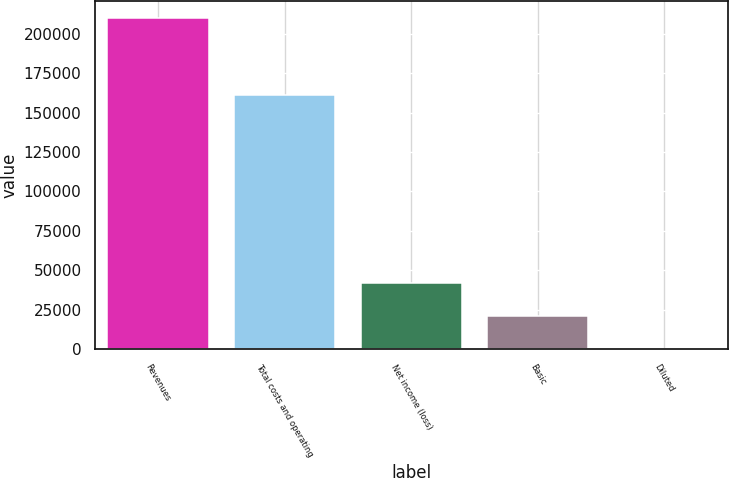<chart> <loc_0><loc_0><loc_500><loc_500><bar_chart><fcel>Revenues<fcel>Total costs and operating<fcel>Net income (loss)<fcel>Basic<fcel>Diluted<nl><fcel>210015<fcel>161048<fcel>42003.2<fcel>21001.7<fcel>0.25<nl></chart> 